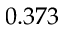Convert formula to latex. <formula><loc_0><loc_0><loc_500><loc_500>0 . 3 7 3</formula> 